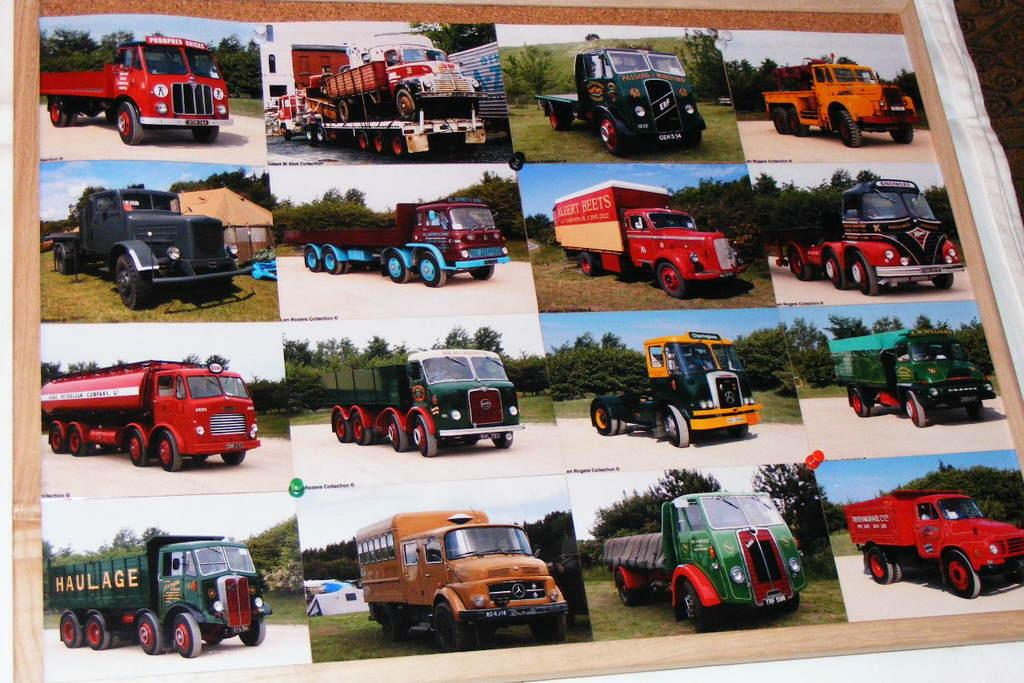What is depicted in the photos in the image? The photos in the image are of vehicles. How are the photos displayed in the image? The photos are pinned on a board. What is the board placed on in the image? The board is placed on a cloth. What type of verse can be seen written on the board in the image? There is no verse present on the board in the image; it only contains photos of vehicles. Can you tell me how many visitors are visible in the image? There are no visitors present in the image; it only features a board with photos of vehicles placed on a cloth. 